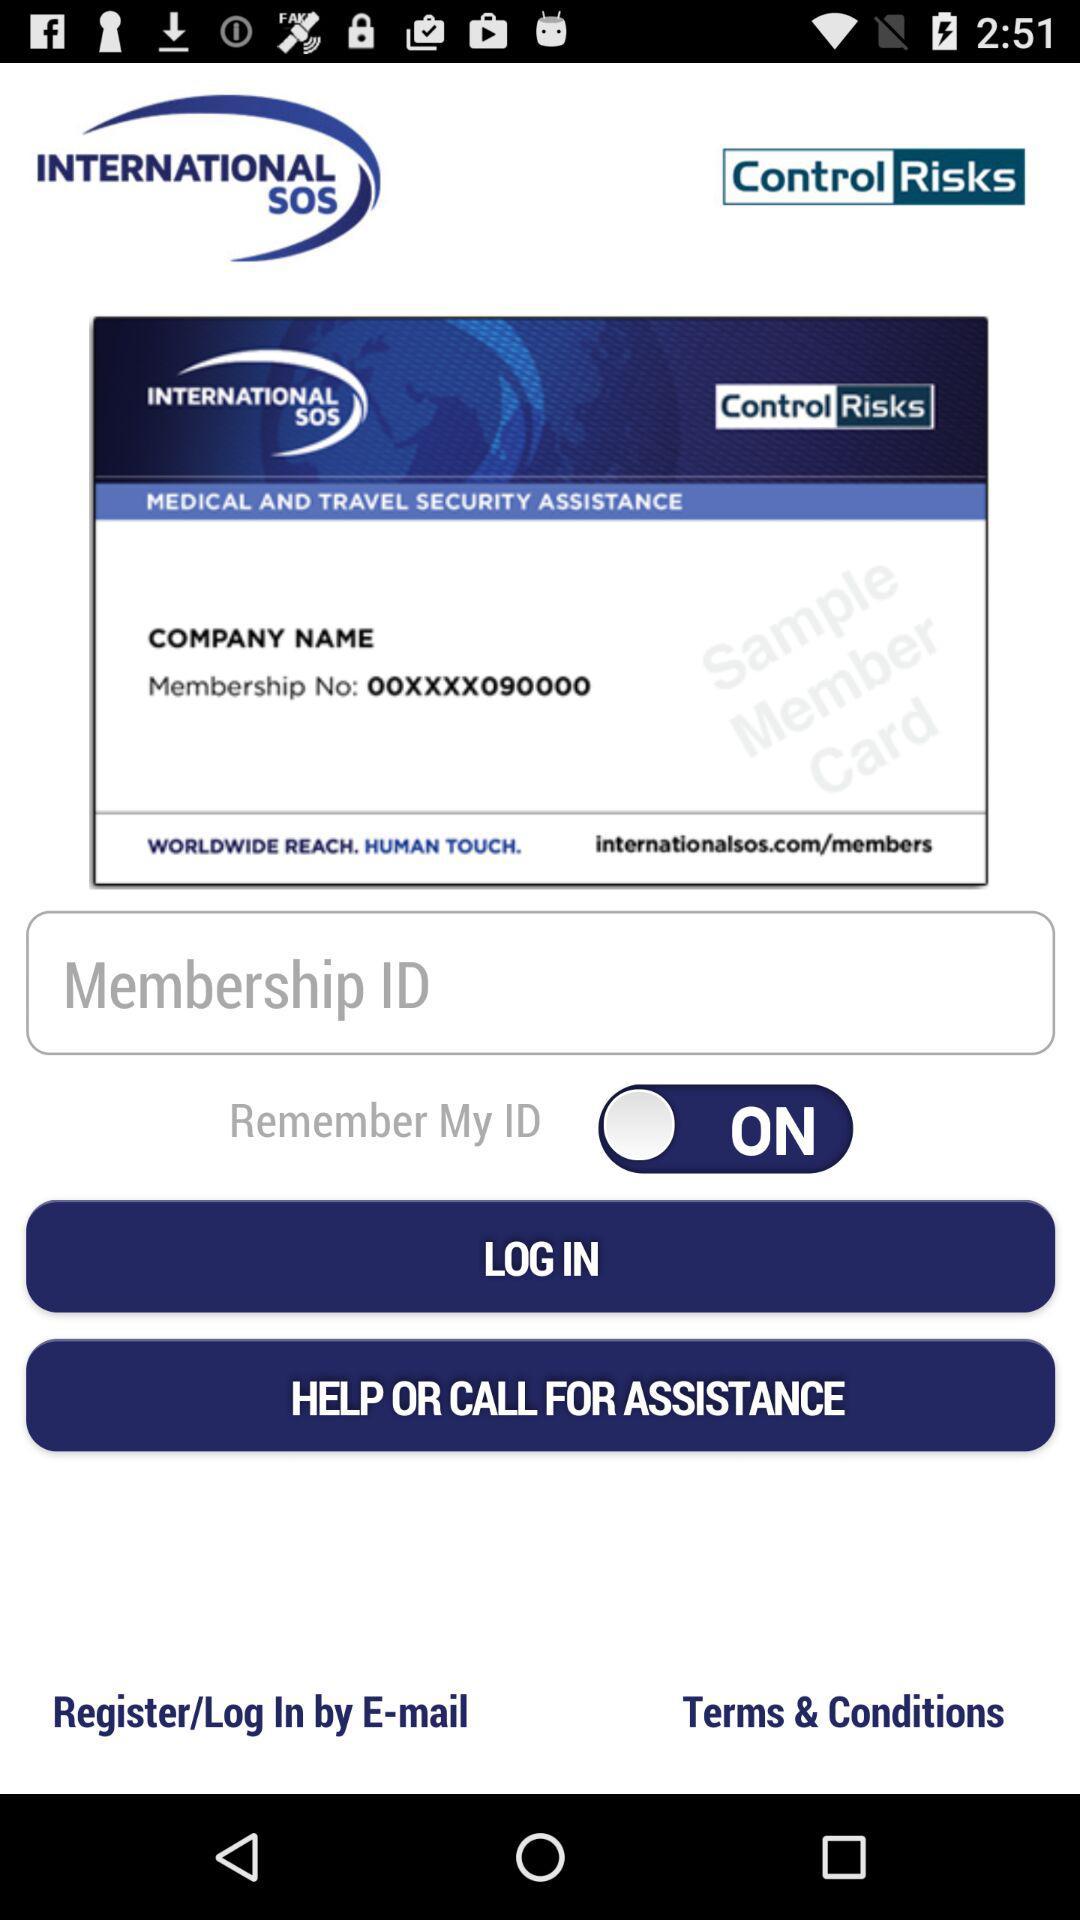What is the status of "Remember My ID"? The status is "on". 